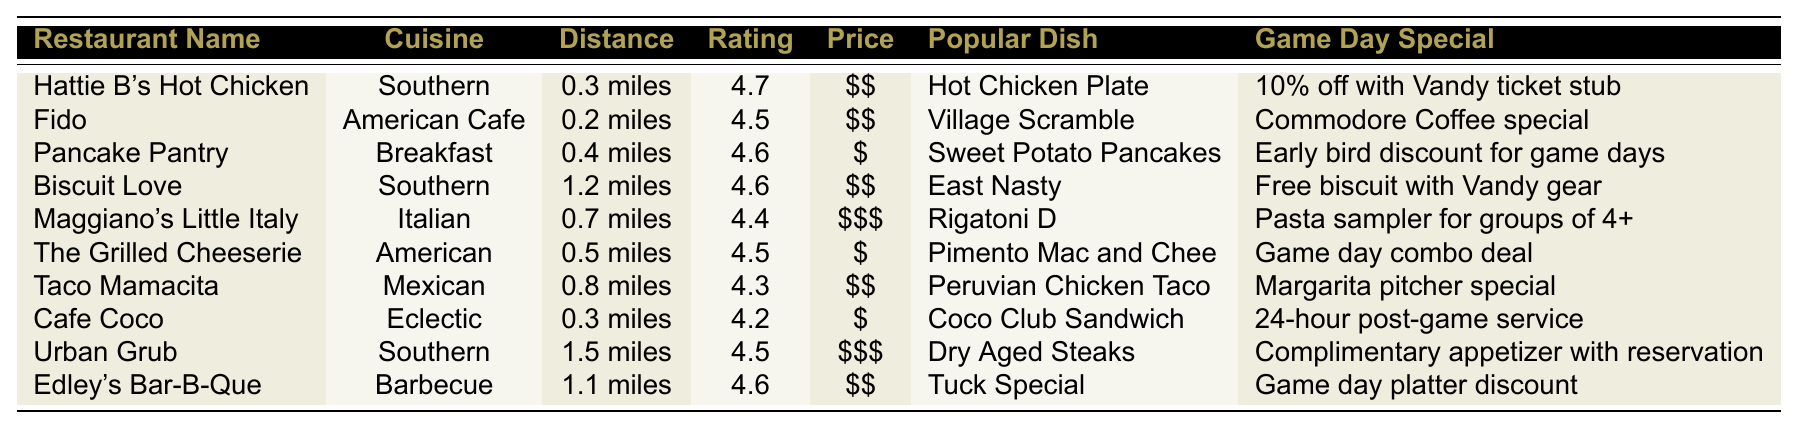What is the highest rated restaurant near Vanderbilt University? The table lists the ratings of the restaurants, with Hattie B's Hot Chicken having the highest rating of 4.7.
Answer: Hattie B's Hot Chicken Which two restaurants are closest to Vanderbilt University? The distances listed for the restaurants show that Fido (0.2 miles) and Hattie B's Hot Chicken (0.3 miles) are the two closest.
Answer: Fido and Hattie B's Hot Chicken Is there a restaurant that offers a game day special for free with Vandy gear? Reading the game day specials, Biscuit Love offers a "Free biscuit with Vandy gear," confirming the existence of such a special.
Answer: Yes How many restaurants have a rating of 4.5 or higher? By counting the ratings in the table, we find that six restaurants have ratings of 4.5 or higher: Hattie B's Hot Chicken, Pancake Pantry, Fido, The Grilled Cheeserie, Urban Grub, and Edley's Bar-B-Que.
Answer: Six What is the price range of Maggiano's Little Italy? The price range for Maggiano's Little Italy is listed as "$$$".
Answer: $$$ Which restaurant has the most popular dish listed as "Pimento Mac and Chee"? Looking at the "Popular Dish" column, it is found that "Pimento Mac and Chee" is the popular dish of The Grilled Cheeserie.
Answer: The Grilled Cheeserie How far is Cafe Coco from Vanderbilt University? The distance for Cafe Coco is specified in the table as "0.3 miles."
Answer: 0.3 miles What is the average rating of the restaurants listed in the table? Calculating the average involves adding all the ratings (4.7 + 4.5 + 4.6 + 4.6 + 4.4 + 4.5 + 4.3 + 4.2 + 4.5 + 4.6 = 44.5) and dividing by the number of restaurants (10). The average rating is 44.5 / 10 = 4.45.
Answer: 4.45 Which Cuisine serves a dish called "Sweet Potato Pancakes"? The table indicates that "Sweet Potato Pancakes" is the popular dish for Pancake Pantry, which serves breakfast cuisine.
Answer: Pancake Pantry Is there a restaurant that has a game day special involving a discount? Looking at the game day specials, we can see that Edley's Bar-B-Que offers a "Game day platter discount," confirming discounts are available at some restaurants.
Answer: Yes 